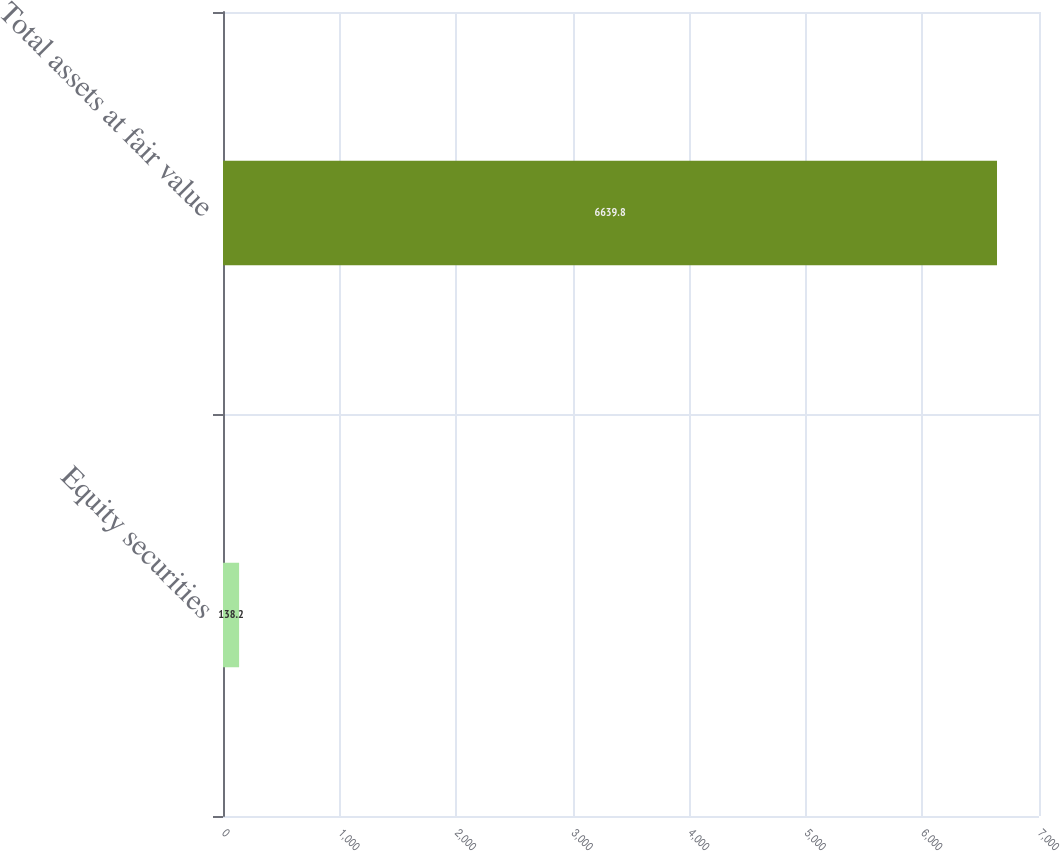Convert chart. <chart><loc_0><loc_0><loc_500><loc_500><bar_chart><fcel>Equity securities<fcel>Total assets at fair value<nl><fcel>138.2<fcel>6639.8<nl></chart> 